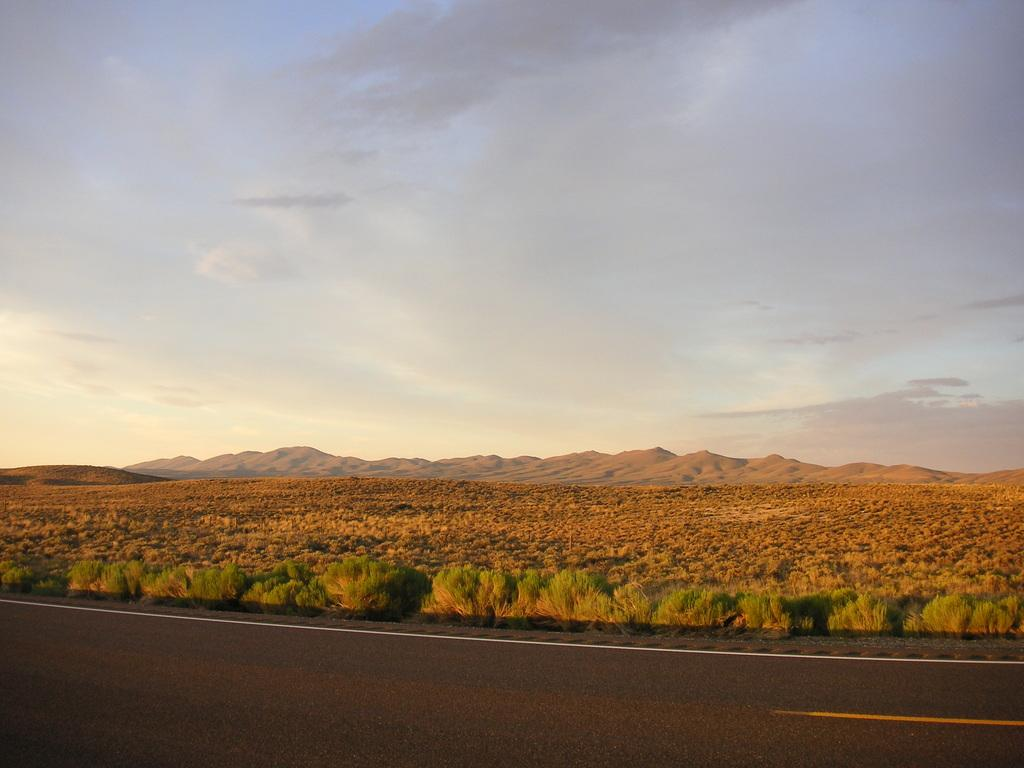What type of natural landscape is featured in the image? There are mountains in the image. What type of vegetation can be seen in the image? There is grass visible in the image, as well as plants. What is the condition of the sky in the image? The sky appears to be cloudy in the image. What type of man-made structures can be seen in the image? There are roads in the image. Can you tell me how many yaks are grazing on the grass in the image? There are no yaks present in the image; it features mountains, grass, plants, and roads. What type of disgust can be seen on the faces of the people in the image? There are no people present in the image, and therefore no facial expressions to analyze. --- 